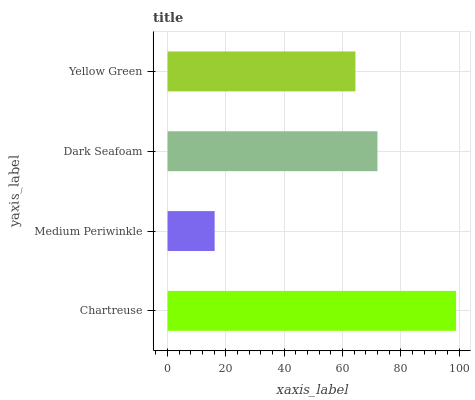Is Medium Periwinkle the minimum?
Answer yes or no. Yes. Is Chartreuse the maximum?
Answer yes or no. Yes. Is Dark Seafoam the minimum?
Answer yes or no. No. Is Dark Seafoam the maximum?
Answer yes or no. No. Is Dark Seafoam greater than Medium Periwinkle?
Answer yes or no. Yes. Is Medium Periwinkle less than Dark Seafoam?
Answer yes or no. Yes. Is Medium Periwinkle greater than Dark Seafoam?
Answer yes or no. No. Is Dark Seafoam less than Medium Periwinkle?
Answer yes or no. No. Is Dark Seafoam the high median?
Answer yes or no. Yes. Is Yellow Green the low median?
Answer yes or no. Yes. Is Yellow Green the high median?
Answer yes or no. No. Is Dark Seafoam the low median?
Answer yes or no. No. 